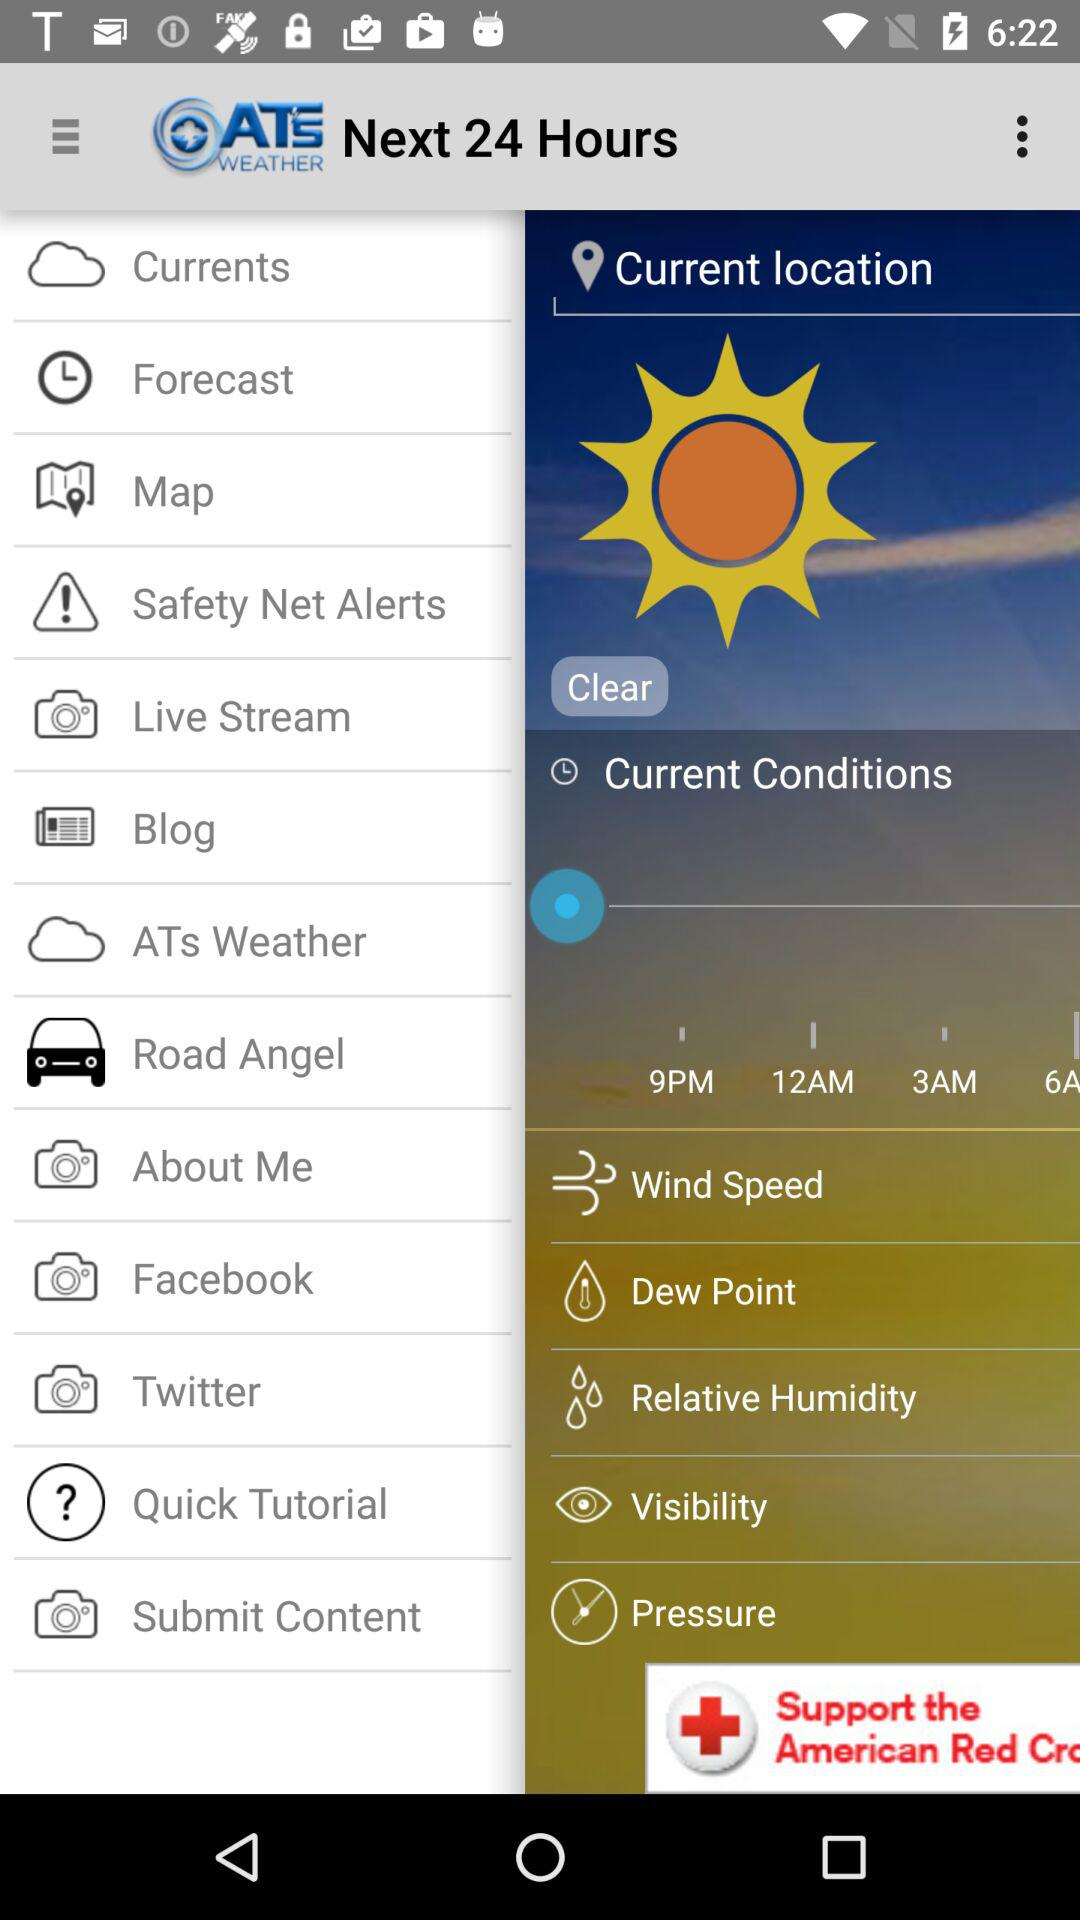How is the weather? The weather is clear. 